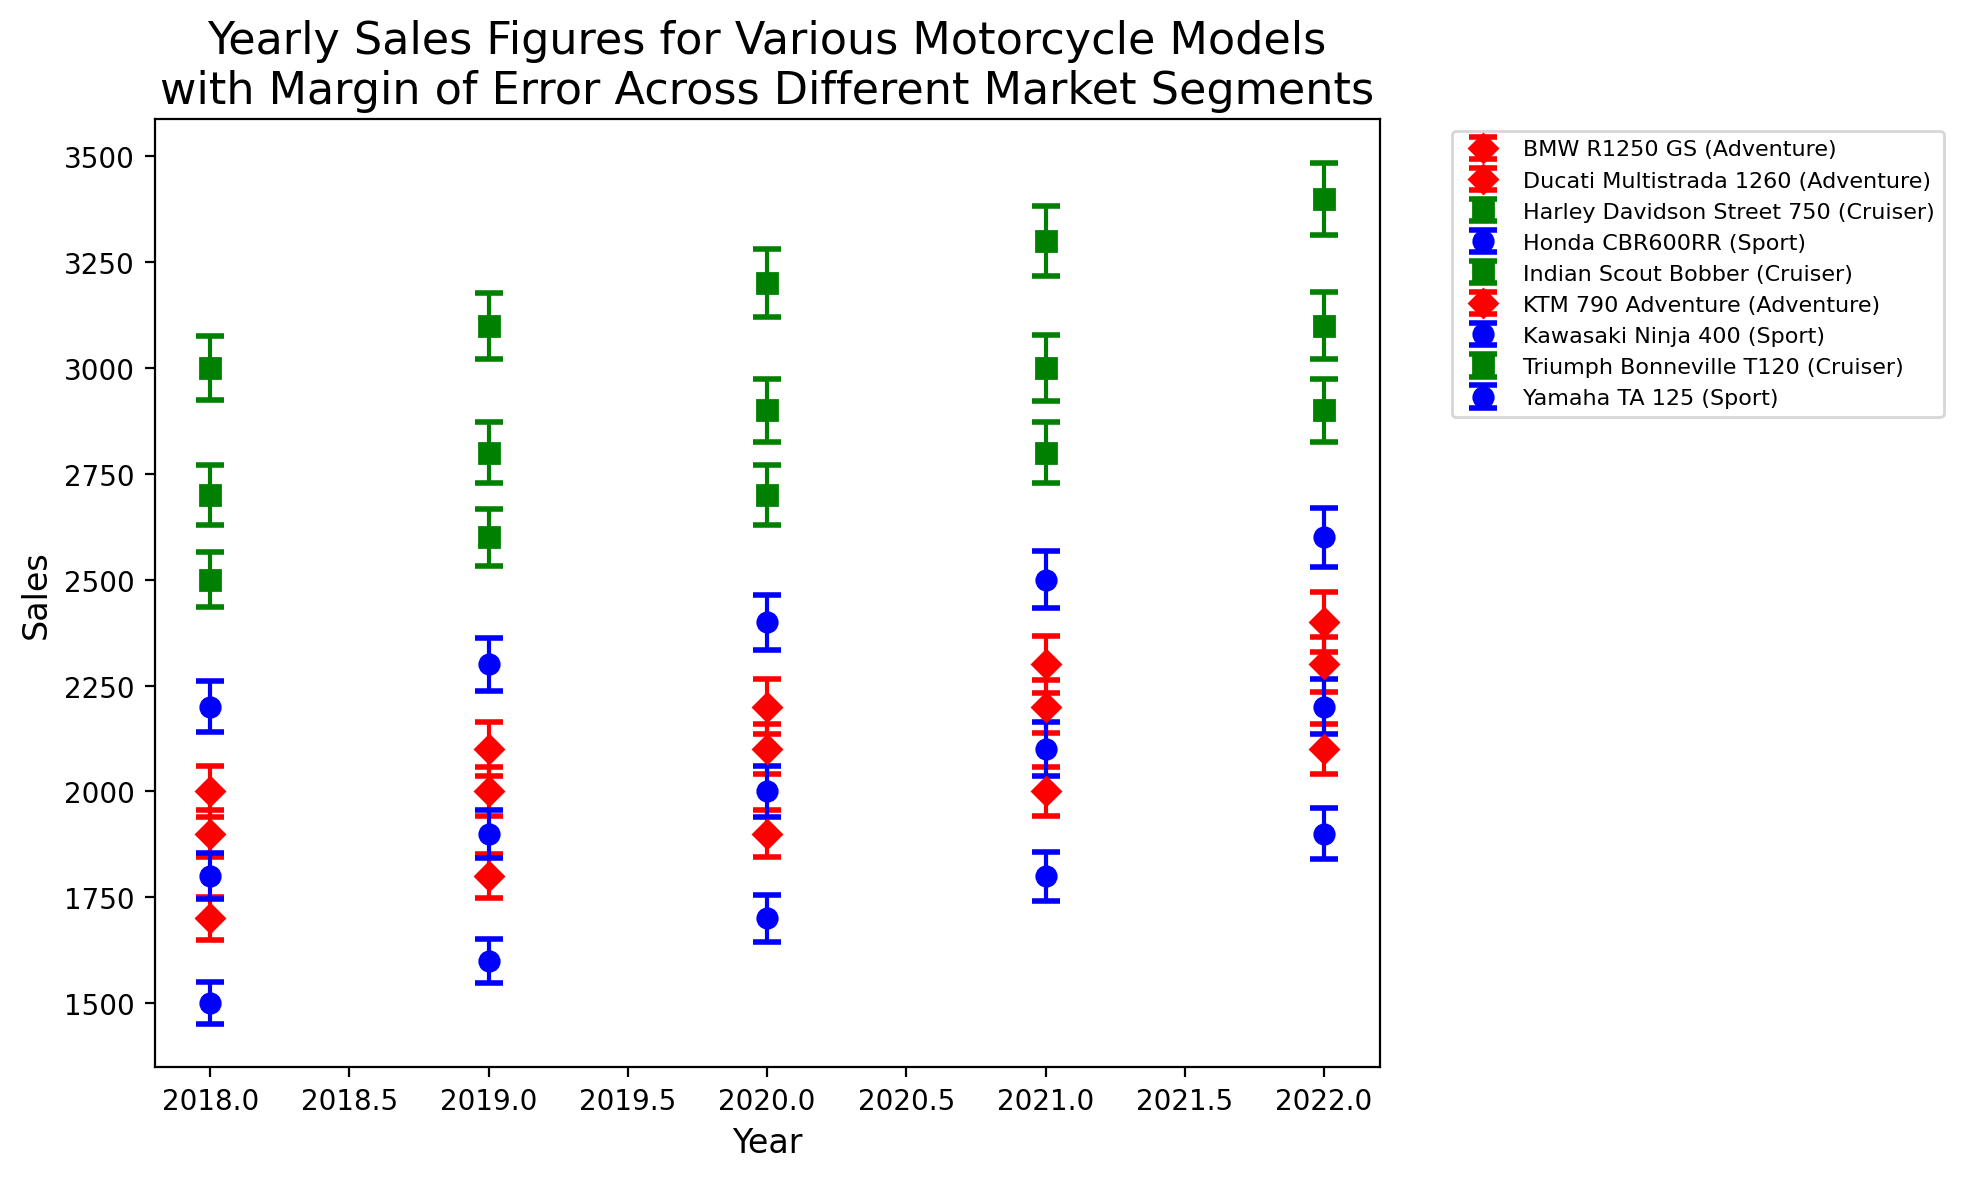Which motorcycle model had the highest sales in 2021? Looking at the figure, identify the peak of each plot for 2021. The Harley Davidson Street 750 in the Cruiser segment has the highest peak for 2021.
Answer: Harley Davidson Street 750 What is the difference in sales between the highest-selling and lowest-selling Adventure segment models in 2020? For the year 2020 under the Adventure segment, note the highest sales (KTM 790 Adventure with 2200 units) and the lowest sales (BMW R1250 GS with 1900 units). The difference is 2200 - 1900.
Answer: 300 Which model showed the most significant increase in sales from 2019 to 2020 in the Sport segment? In the Sport segment, compare sales from 2019 to 2020 for Yamaha TA 125 (1600 to 1700), Honda CBR600RR (1900 to 2000), and Kawasaki Ninja 400 (2300 to 2400). Kawasaki Ninja 400 had the highest increase.
Answer: Kawasaki Ninja 400 What are the average sales figures for the Cruiser segment in 2022? Identify the sales figures for Cruisers in 2022: Harley Davidson Street 750 (3400), Indian Scout Bobber (3100), Triumph Bonneville T120 (2900). Sum these values and divide by 3.
Answer: 3133.3 How did the sales of Yamaha TA 125 change from 2018 to 2022? For each year from 2018 to 2022, note the sales for Yamaha TA 125: (1500, 1600, 1700, 1800, 1900). The sales increased by examining the trend across these years.
Answer: Increased Which market segment generally has the smallest margin of error? By examining the error bars in the figure across segments (Sport, Cruiser, Adventure), the Sport segment consistently has the smallest error bars.
Answer: Sport How do the sales figures for Honda CBR600RR compare between 2019 and 2021? For Honda CBR600RR, compare the sales values: 1900 in 2019 and 2100 in 2021. Sales increased by 200 units (2100 - 1900).
Answer: Increased What visually noticeable trend is shared by all models in the Cruiser segment from 2018 to 2022? By examining the Cruiser segment over the years, it can be noticed that all models show an increasing trend in sales.
Answer: Increasing trend Which Adventure model had the highest margin of error in 2021? Look at the error bars for Adventure models in 2021: BMW R1250 GS (58), Ducati Multistrada 1260 (63), KTM 790 Adventure (68). KTM 790 Adventure has the highest margin of error.
Answer: KTM 790 Adventure Compare the sales trends of the Ducati Multistrada 1260 and the BMW R1250 GS from 2018 to 2022. Examine the sales for both models year-by-year. Ducati Multistrada 1260 shows an increasing trend while BMW R1250 GS also shows an increasing trend, but starting from a lower base and with more variability compared to Ducati.
Answer: Similar increasing trends, Ducati starting higher 